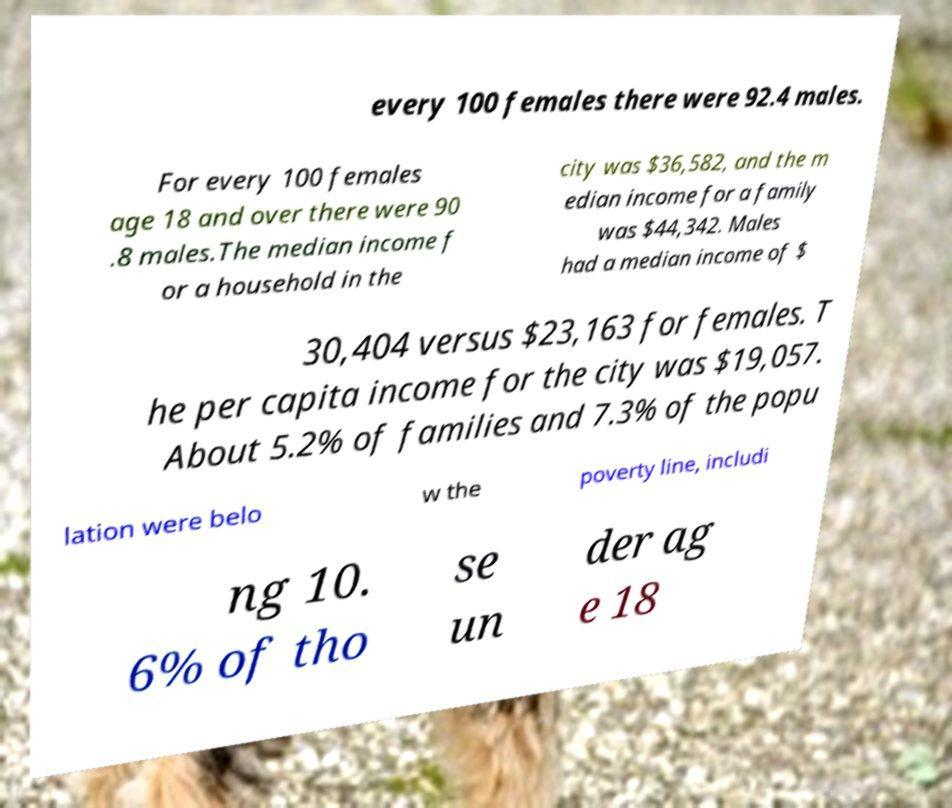Could you assist in decoding the text presented in this image and type it out clearly? every 100 females there were 92.4 males. For every 100 females age 18 and over there were 90 .8 males.The median income f or a household in the city was $36,582, and the m edian income for a family was $44,342. Males had a median income of $ 30,404 versus $23,163 for females. T he per capita income for the city was $19,057. About 5.2% of families and 7.3% of the popu lation were belo w the poverty line, includi ng 10. 6% of tho se un der ag e 18 